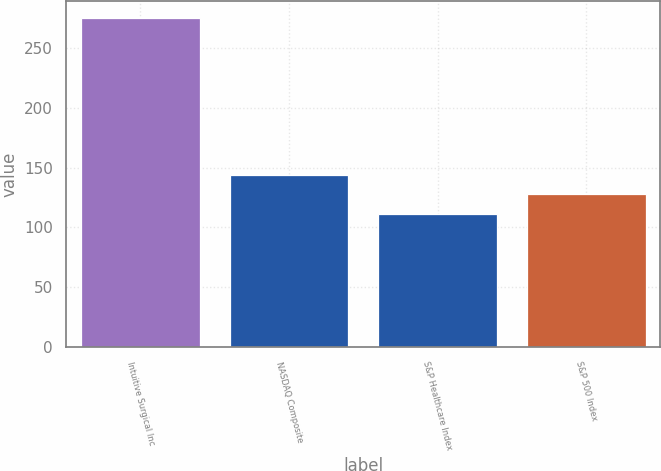<chart> <loc_0><loc_0><loc_500><loc_500><bar_chart><fcel>Intuitive Surgical Inc<fcel>NASDAQ Composite<fcel>S&P Healthcare Index<fcel>S&P 500 Index<nl><fcel>275.43<fcel>144.27<fcel>111.49<fcel>127.88<nl></chart> 